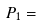<formula> <loc_0><loc_0><loc_500><loc_500>P _ { 1 } =</formula> 